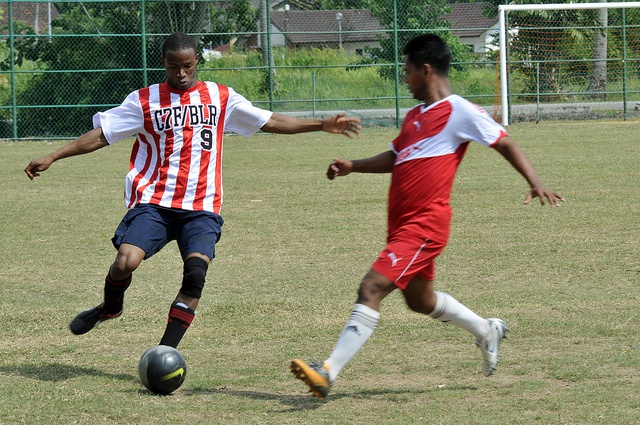Describe the objects in this image and their specific colors. I can see people in teal, black, lavender, tan, and darkgray tones, people in teal, black, tan, brown, and maroon tones, and sports ball in teal, black, gray, darkgray, and purple tones in this image. 